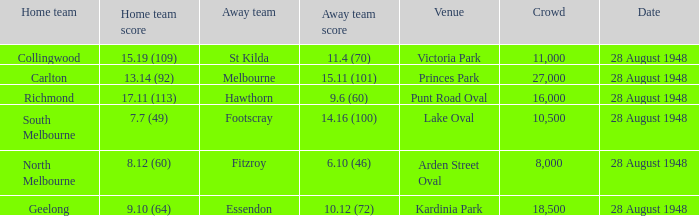Which home team possesses a team score of North Melbourne. 